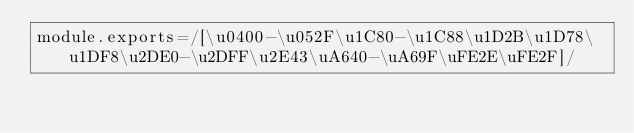Convert code to text. <code><loc_0><loc_0><loc_500><loc_500><_JavaScript_>module.exports=/[\u0400-\u052F\u1C80-\u1C88\u1D2B\u1D78\u1DF8\u2DE0-\u2DFF\u2E43\uA640-\uA69F\uFE2E\uFE2F]/</code> 